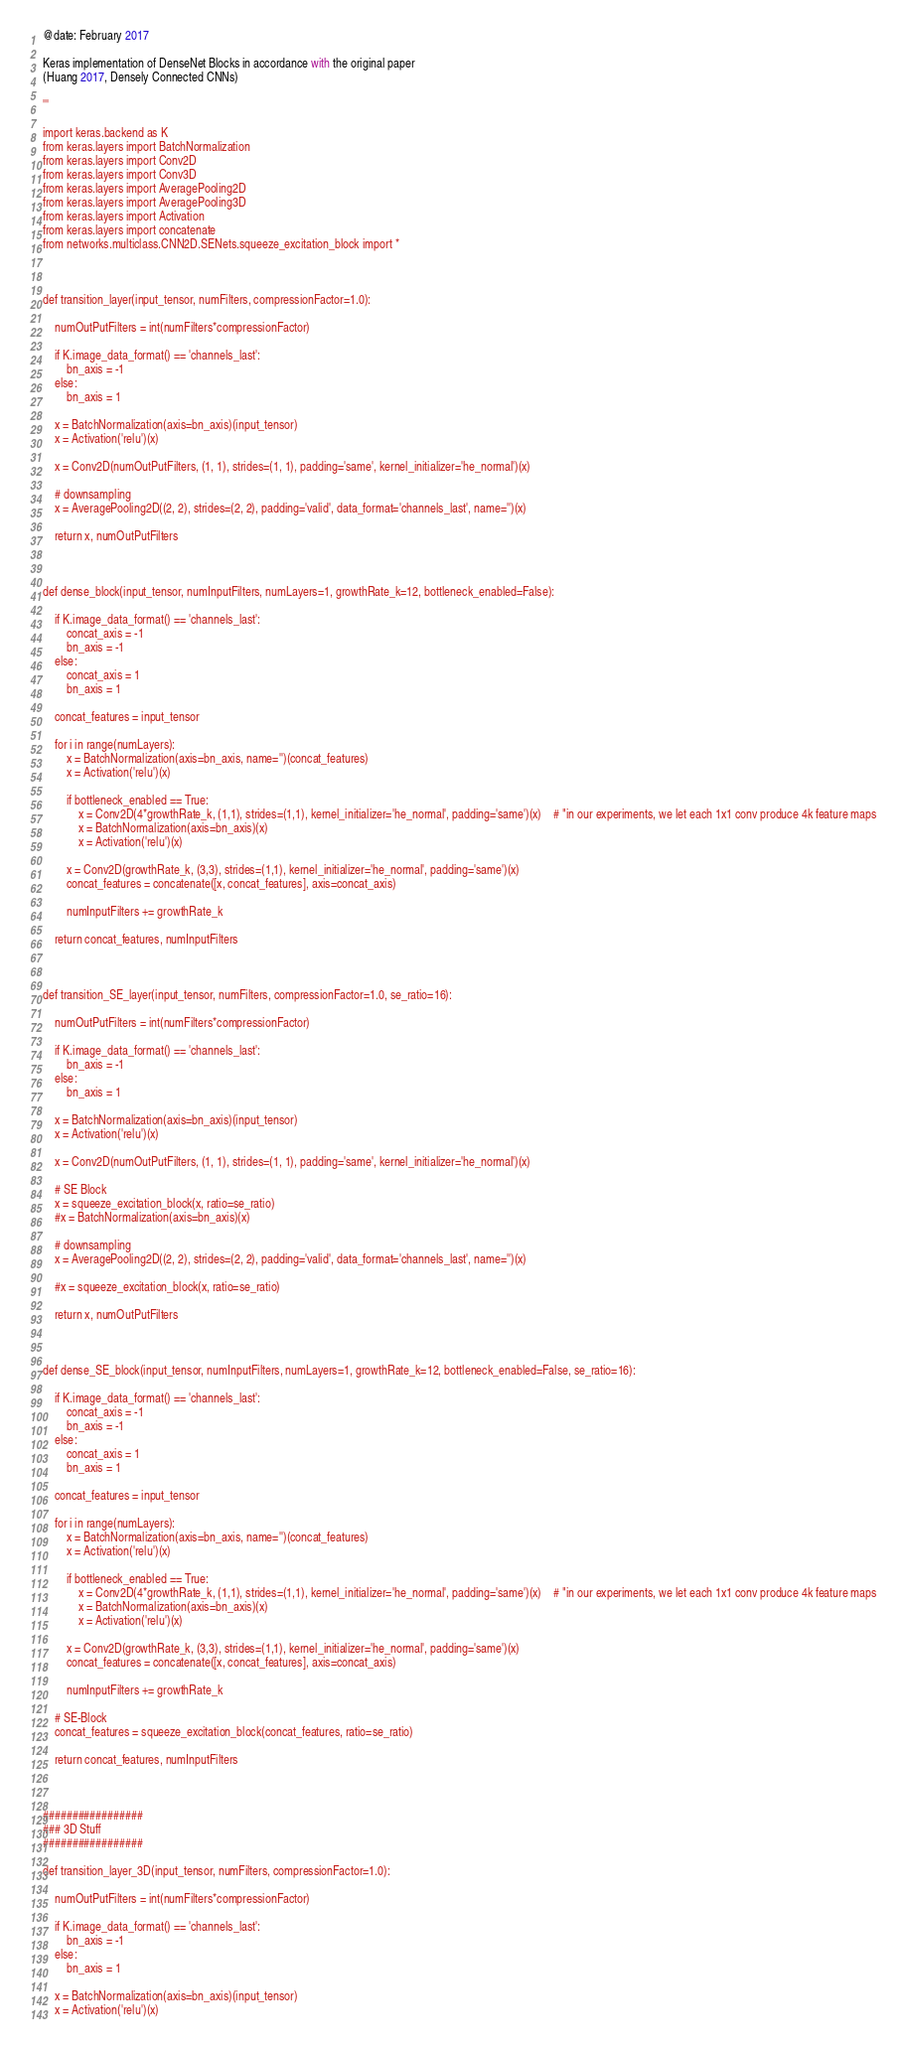Convert code to text. <code><loc_0><loc_0><loc_500><loc_500><_Python_>@date: February 2017

Keras implementation of DenseNet Blocks in accordance with the original paper
(Huang 2017, Densely Connected CNNs)

'''

import keras.backend as K
from keras.layers import BatchNormalization
from keras.layers import Conv2D
from keras.layers import Conv3D
from keras.layers import AveragePooling2D
from keras.layers import AveragePooling3D
from keras.layers import Activation
from keras.layers import concatenate
from networks.multiclass.CNN2D.SENets.squeeze_excitation_block import *



def transition_layer(input_tensor, numFilters, compressionFactor=1.0):

    numOutPutFilters = int(numFilters*compressionFactor)

    if K.image_data_format() == 'channels_last':
        bn_axis = -1
    else:
        bn_axis = 1

    x = BatchNormalization(axis=bn_axis)(input_tensor)
    x = Activation('relu')(x)

    x = Conv2D(numOutPutFilters, (1, 1), strides=(1, 1), padding='same', kernel_initializer='he_normal')(x)

    # downsampling
    x = AveragePooling2D((2, 2), strides=(2, 2), padding='valid', data_format='channels_last', name='')(x)

    return x, numOutPutFilters



def dense_block(input_tensor, numInputFilters, numLayers=1, growthRate_k=12, bottleneck_enabled=False):

    if K.image_data_format() == 'channels_last':
        concat_axis = -1
        bn_axis = -1
    else:
        concat_axis = 1
        bn_axis = 1

    concat_features = input_tensor

    for i in range(numLayers):
        x = BatchNormalization(axis=bn_axis, name='')(concat_features)
        x = Activation('relu')(x)

        if bottleneck_enabled == True:
            x = Conv2D(4*growthRate_k, (1,1), strides=(1,1), kernel_initializer='he_normal', padding='same')(x)    # "in our experiments, we let each 1x1 conv produce 4k feature maps
            x = BatchNormalization(axis=bn_axis)(x)
            x = Activation('relu')(x)

        x = Conv2D(growthRate_k, (3,3), strides=(1,1), kernel_initializer='he_normal', padding='same')(x)
        concat_features = concatenate([x, concat_features], axis=concat_axis)

        numInputFilters += growthRate_k

    return concat_features, numInputFilters



def transition_SE_layer(input_tensor, numFilters, compressionFactor=1.0, se_ratio=16):

    numOutPutFilters = int(numFilters*compressionFactor)

    if K.image_data_format() == 'channels_last':
        bn_axis = -1
    else:
        bn_axis = 1

    x = BatchNormalization(axis=bn_axis)(input_tensor)
    x = Activation('relu')(x)

    x = Conv2D(numOutPutFilters, (1, 1), strides=(1, 1), padding='same', kernel_initializer='he_normal')(x)

    # SE Block
    x = squeeze_excitation_block(x, ratio=se_ratio)
    #x = BatchNormalization(axis=bn_axis)(x)

    # downsampling
    x = AveragePooling2D((2, 2), strides=(2, 2), padding='valid', data_format='channels_last', name='')(x)

    #x = squeeze_excitation_block(x, ratio=se_ratio)

    return x, numOutPutFilters



def dense_SE_block(input_tensor, numInputFilters, numLayers=1, growthRate_k=12, bottleneck_enabled=False, se_ratio=16):

    if K.image_data_format() == 'channels_last':
        concat_axis = -1
        bn_axis = -1
    else:
        concat_axis = 1
        bn_axis = 1

    concat_features = input_tensor

    for i in range(numLayers):
        x = BatchNormalization(axis=bn_axis, name='')(concat_features)
        x = Activation('relu')(x)

        if bottleneck_enabled == True:
            x = Conv2D(4*growthRate_k, (1,1), strides=(1,1), kernel_initializer='he_normal', padding='same')(x)    # "in our experiments, we let each 1x1 conv produce 4k feature maps
            x = BatchNormalization(axis=bn_axis)(x)
            x = Activation('relu')(x)

        x = Conv2D(growthRate_k, (3,3), strides=(1,1), kernel_initializer='he_normal', padding='same')(x)
        concat_features = concatenate([x, concat_features], axis=concat_axis)

        numInputFilters += growthRate_k

    # SE-Block
    concat_features = squeeze_excitation_block(concat_features, ratio=se_ratio)

    return concat_features, numInputFilters



#################
### 3D Stuff
#################

def transition_layer_3D(input_tensor, numFilters, compressionFactor=1.0):

    numOutPutFilters = int(numFilters*compressionFactor)

    if K.image_data_format() == 'channels_last':
        bn_axis = -1
    else:
        bn_axis = 1

    x = BatchNormalization(axis=bn_axis)(input_tensor)
    x = Activation('relu')(x)
</code> 